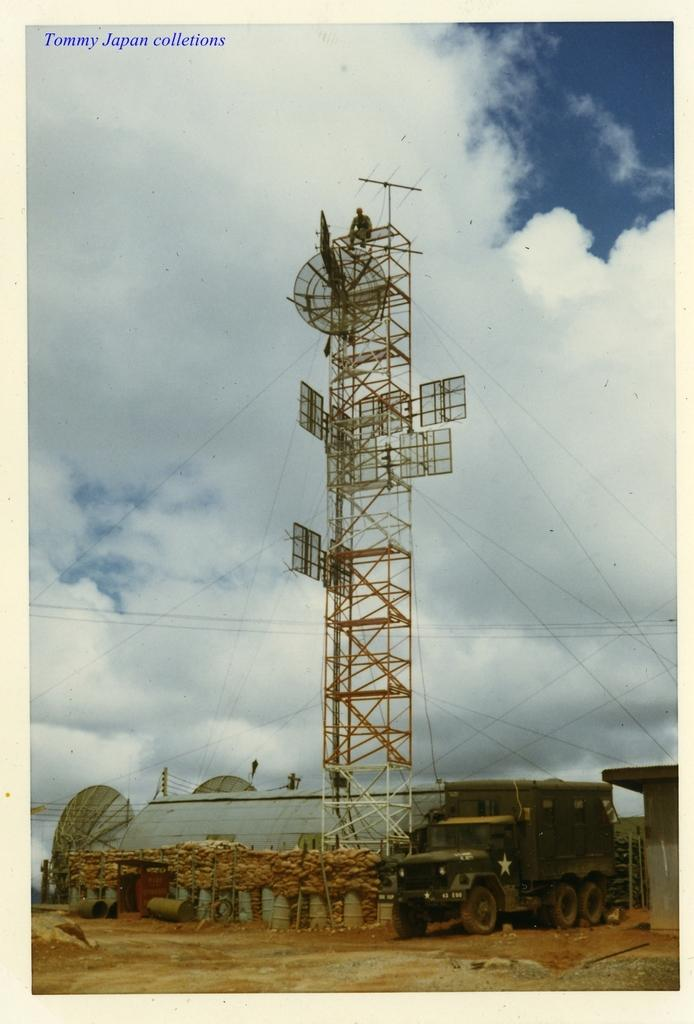What is the main subject of the image? There is a vehicle in the image. What other structures are present in the image? There are shelters and a tower in the image. Where are the tower and shelters located in the image? The tower and shelters are located at the bottom of the image. What can be seen in the background of the image? The sky is visible in the background of the image. How would you describe the sky in the image? The sky appears to be cloudy. What type of meal is being served at the angle in the image? There is no meal or angle present in the image; it features a vehicle, shelters, a tower, and a cloudy sky. 